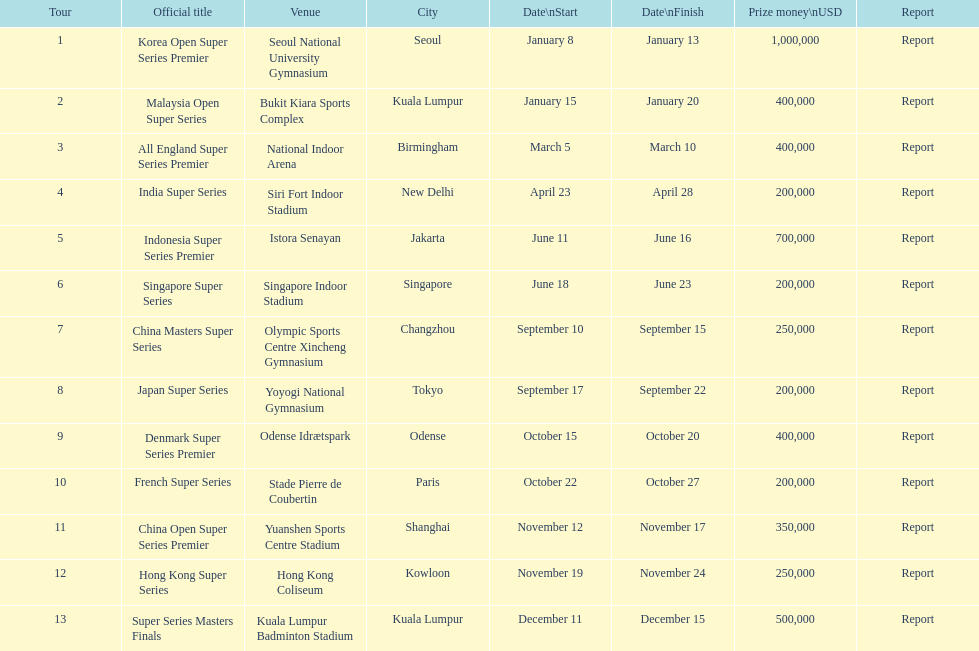Does the malaysia open super series offer a larger or smaller payout compared to the french super series? More. 